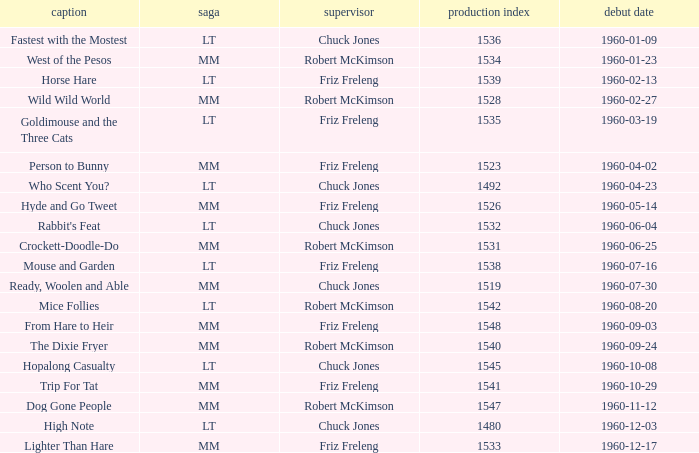Write the full table. {'header': ['caption', 'saga', 'supervisor', 'production index', 'debut date'], 'rows': [['Fastest with the Mostest', 'LT', 'Chuck Jones', '1536', '1960-01-09'], ['West of the Pesos', 'MM', 'Robert McKimson', '1534', '1960-01-23'], ['Horse Hare', 'LT', 'Friz Freleng', '1539', '1960-02-13'], ['Wild Wild World', 'MM', 'Robert McKimson', '1528', '1960-02-27'], ['Goldimouse and the Three Cats', 'LT', 'Friz Freleng', '1535', '1960-03-19'], ['Person to Bunny', 'MM', 'Friz Freleng', '1523', '1960-04-02'], ['Who Scent You?', 'LT', 'Chuck Jones', '1492', '1960-04-23'], ['Hyde and Go Tweet', 'MM', 'Friz Freleng', '1526', '1960-05-14'], ["Rabbit's Feat", 'LT', 'Chuck Jones', '1532', '1960-06-04'], ['Crockett-Doodle-Do', 'MM', 'Robert McKimson', '1531', '1960-06-25'], ['Mouse and Garden', 'LT', 'Friz Freleng', '1538', '1960-07-16'], ['Ready, Woolen and Able', 'MM', 'Chuck Jones', '1519', '1960-07-30'], ['Mice Follies', 'LT', 'Robert McKimson', '1542', '1960-08-20'], ['From Hare to Heir', 'MM', 'Friz Freleng', '1548', '1960-09-03'], ['The Dixie Fryer', 'MM', 'Robert McKimson', '1540', '1960-09-24'], ['Hopalong Casualty', 'LT', 'Chuck Jones', '1545', '1960-10-08'], ['Trip For Tat', 'MM', 'Friz Freleng', '1541', '1960-10-29'], ['Dog Gone People', 'MM', 'Robert McKimson', '1547', '1960-11-12'], ['High Note', 'LT', 'Chuck Jones', '1480', '1960-12-03'], ['Lighter Than Hare', 'MM', 'Friz Freleng', '1533', '1960-12-17']]} What is the Series number of the episode with a production number of 1547? MM. 